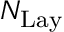Convert formula to latex. <formula><loc_0><loc_0><loc_500><loc_500>N _ { L a y }</formula> 